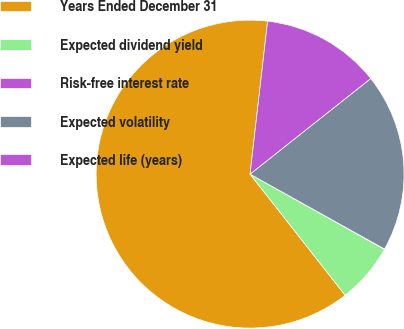<chart> <loc_0><loc_0><loc_500><loc_500><pie_chart><fcel>Years Ended December 31<fcel>Expected dividend yield<fcel>Risk-free interest rate<fcel>Expected volatility<fcel>Expected life (years)<nl><fcel>62.41%<fcel>6.28%<fcel>0.04%<fcel>18.75%<fcel>12.52%<nl></chart> 